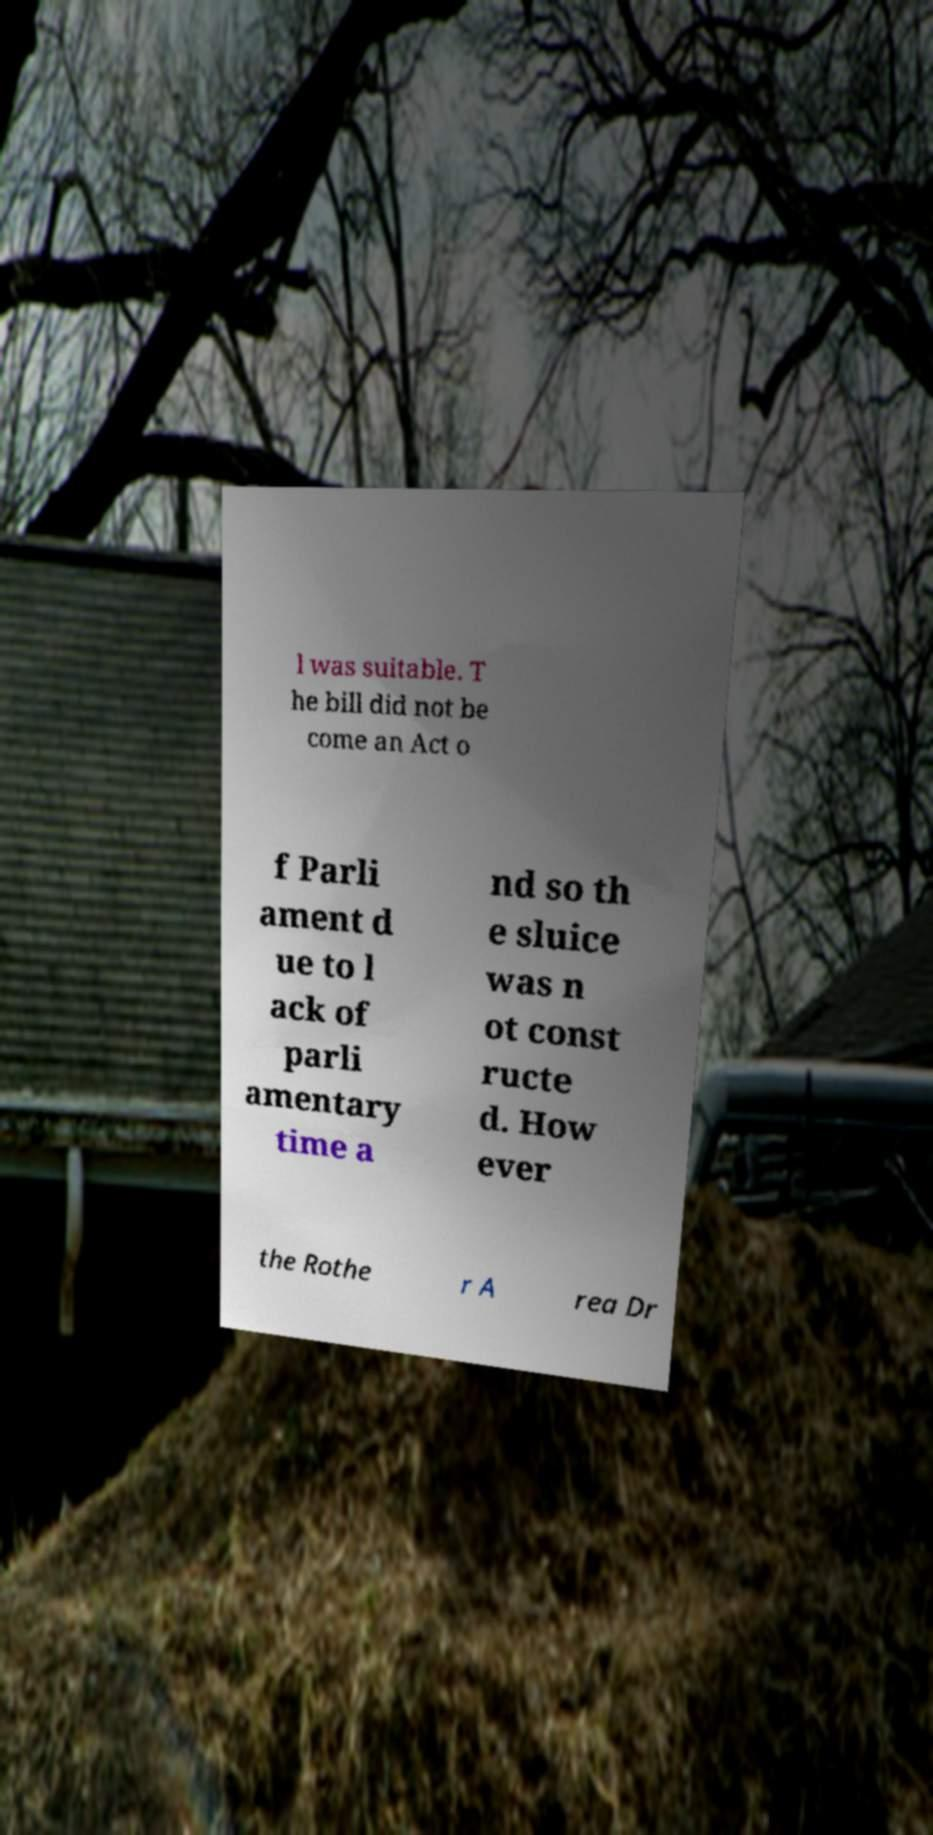Please read and relay the text visible in this image. What does it say? l was suitable. T he bill did not be come an Act o f Parli ament d ue to l ack of parli amentary time a nd so th e sluice was n ot const ructe d. How ever the Rothe r A rea Dr 